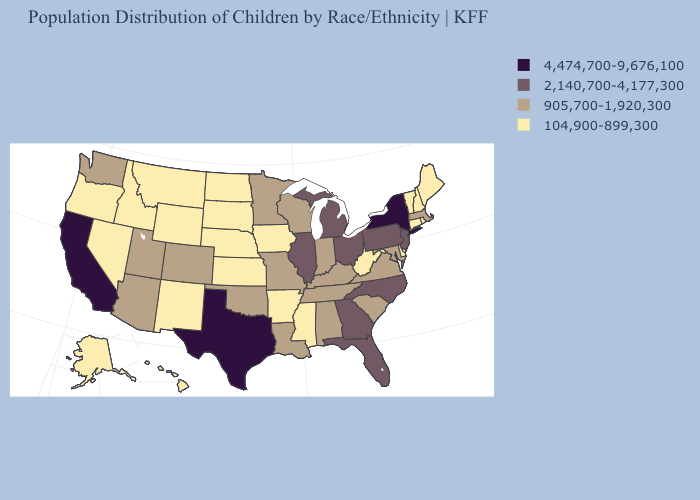What is the highest value in states that border Connecticut?
Quick response, please. 4,474,700-9,676,100. Does New Mexico have the highest value in the USA?
Keep it brief. No. Does the map have missing data?
Keep it brief. No. What is the value of Connecticut?
Answer briefly. 104,900-899,300. Which states have the lowest value in the Northeast?
Concise answer only. Connecticut, Maine, New Hampshire, Rhode Island, Vermont. Which states hav the highest value in the MidWest?
Answer briefly. Illinois, Michigan, Ohio. Name the states that have a value in the range 905,700-1,920,300?
Quick response, please. Alabama, Arizona, Colorado, Indiana, Kentucky, Louisiana, Maryland, Massachusetts, Minnesota, Missouri, Oklahoma, South Carolina, Tennessee, Utah, Virginia, Washington, Wisconsin. Name the states that have a value in the range 104,900-899,300?
Answer briefly. Alaska, Arkansas, Connecticut, Delaware, Hawaii, Idaho, Iowa, Kansas, Maine, Mississippi, Montana, Nebraska, Nevada, New Hampshire, New Mexico, North Dakota, Oregon, Rhode Island, South Dakota, Vermont, West Virginia, Wyoming. What is the lowest value in the Northeast?
Concise answer only. 104,900-899,300. What is the value of Arkansas?
Short answer required. 104,900-899,300. Does the map have missing data?
Answer briefly. No. Name the states that have a value in the range 104,900-899,300?
Be succinct. Alaska, Arkansas, Connecticut, Delaware, Hawaii, Idaho, Iowa, Kansas, Maine, Mississippi, Montana, Nebraska, Nevada, New Hampshire, New Mexico, North Dakota, Oregon, Rhode Island, South Dakota, Vermont, West Virginia, Wyoming. What is the value of Pennsylvania?
Answer briefly. 2,140,700-4,177,300. Among the states that border Arkansas , does Texas have the highest value?
Give a very brief answer. Yes. Name the states that have a value in the range 104,900-899,300?
Quick response, please. Alaska, Arkansas, Connecticut, Delaware, Hawaii, Idaho, Iowa, Kansas, Maine, Mississippi, Montana, Nebraska, Nevada, New Hampshire, New Mexico, North Dakota, Oregon, Rhode Island, South Dakota, Vermont, West Virginia, Wyoming. 